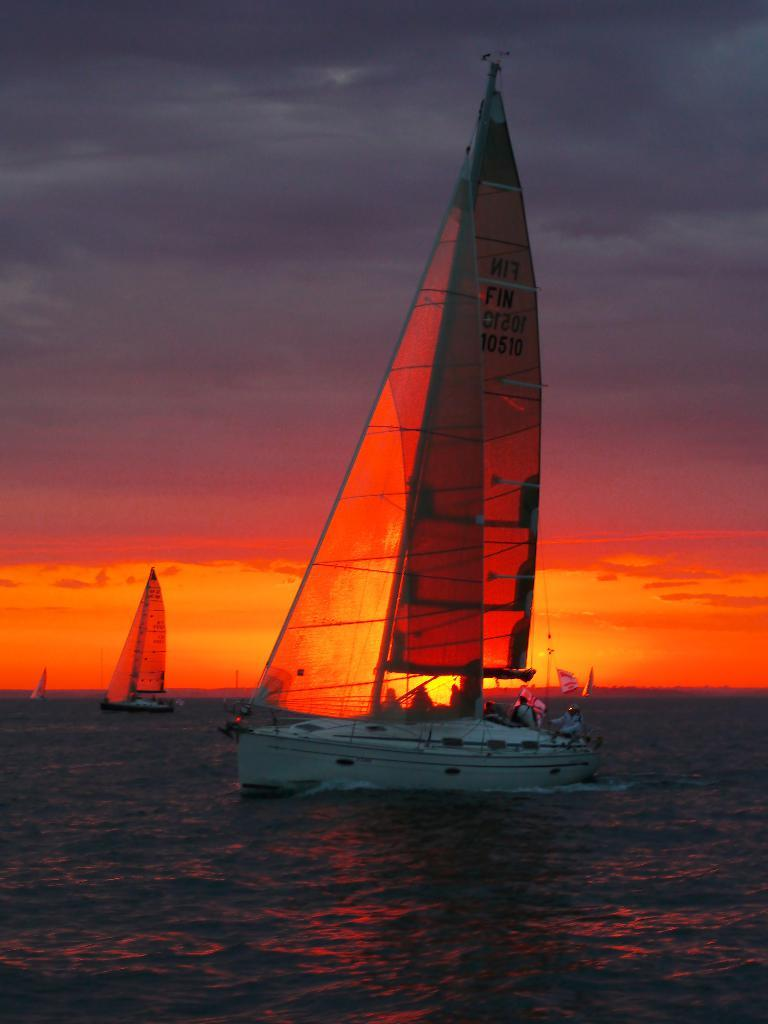What type of watercraft is in the image? There is a sailboat in the image. Who is in the sailboat? People are sitting in the sailboat. Are there any other sailboats visible in the image? Yes, there are other sailboats visible in the image. What type of banana is being used as a guide for the sailboat in the image? There is no banana present in the image, and therefore it cannot be used as a guide for the sailboat. 